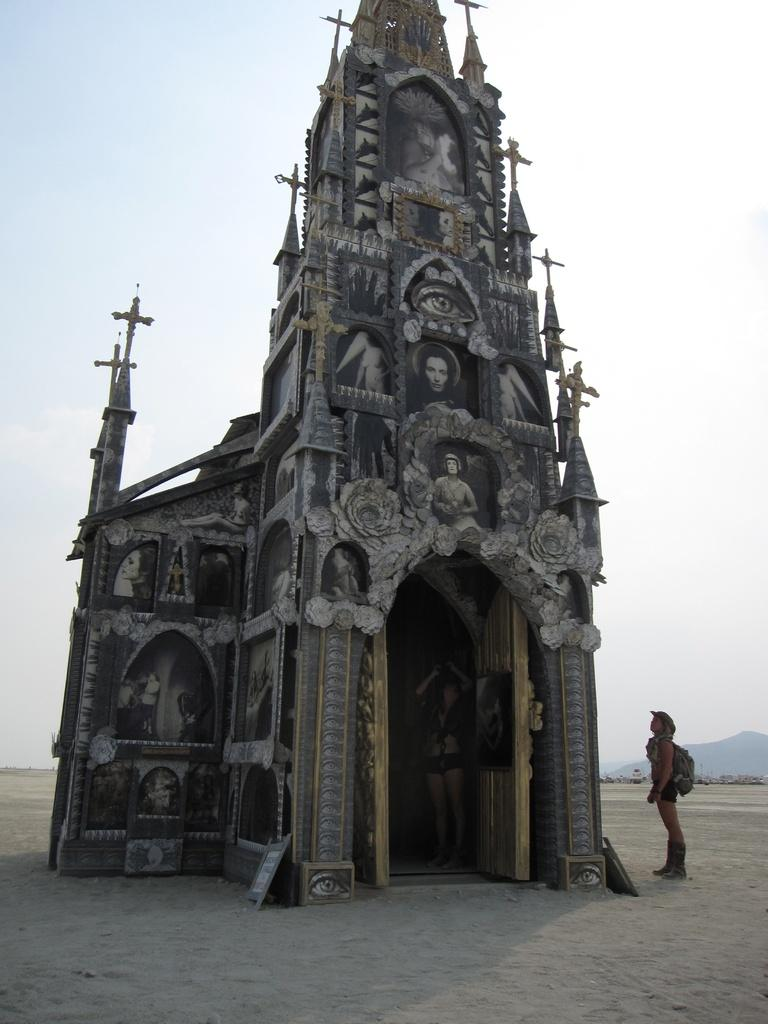What is the main subject in the center of the image? There is a Parish in the center of the image. What else can be seen in the image besides the Parish? There are persons standing in the image. What type of bushes can be seen growing around the Parish in the image? There is no mention of bushes in the image; it only features a Parish and persons standing. What type of vacation is being depicted in the image? There is no indication of a vacation in the image; it simply shows a Parish and persons standing. 